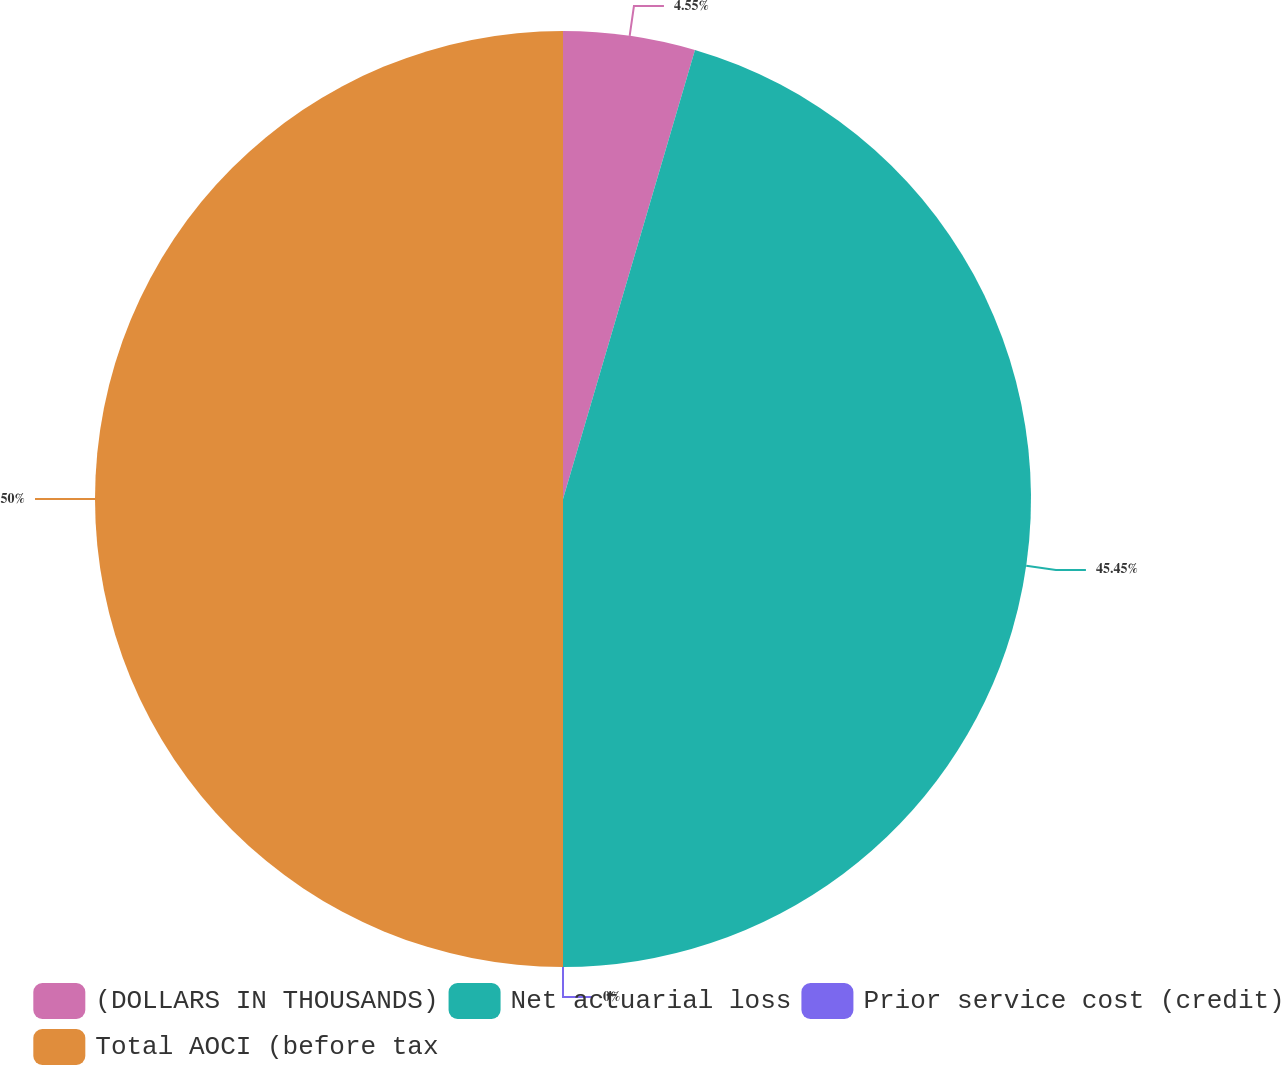Convert chart to OTSL. <chart><loc_0><loc_0><loc_500><loc_500><pie_chart><fcel>(DOLLARS IN THOUSANDS)<fcel>Net actuarial loss<fcel>Prior service cost (credit)<fcel>Total AOCI (before tax<nl><fcel>4.55%<fcel>45.45%<fcel>0.0%<fcel>50.0%<nl></chart> 